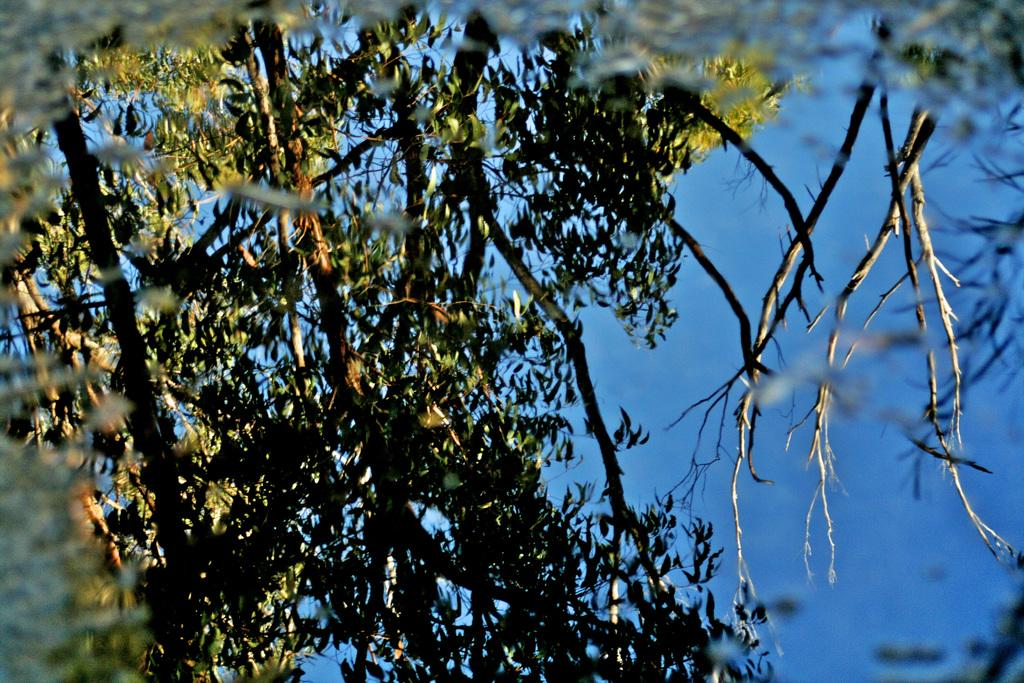What type of plant can be seen in the image? There is a tree in the image. What part of the natural environment is visible in the image? The sky is visible in the background of the image. What color is the background of the image? The background of the image is blue in color. What type of locket can be seen hanging from the tree in the image? There is no locket present in the image; it only features a tree and the blue sky in the background. 